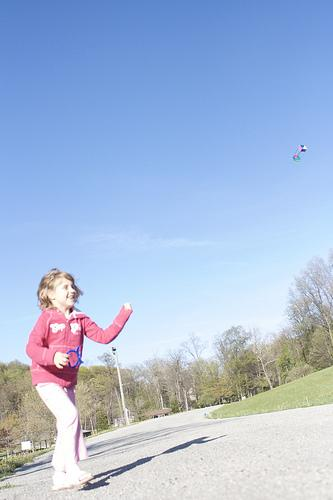What is the girl wearing in the image? The girl is wearing a pink hoodie, pink pants, and white shoes. Can you describe the grass in the image? The grass is green, trimmed, and covers a large section beside the sidewalk. Enumerate some distinctive object features in the image. Multicolored kite, pink jacket with white letters and a zipper, blue handle to a kite, and shadow of a girl on the ground. What type of environment is the image set in? The image is set outdoors, with a grassy area, a sidewalk, and blue sky. What objects can be seen in the background of the image? A tree with no leaves, a tall gray lamp pole, and a clear blue sky. How many trees are in the image, and what are their states? There are two trees, one with leaves and one without leaves. Determine the approximate number of objects in the image. There are around 30 objects in the image. Analyze the interaction between the girl and the kite. The girl is holding the blue handle of the kite, flying it in the air, and running on a path while having a fun time. What is the emotional state of the girl in the image? The girl is happy and smiling. Identify the main activity and the person involved in the image. A blonde little girl flying a colorful kite in the sky. 